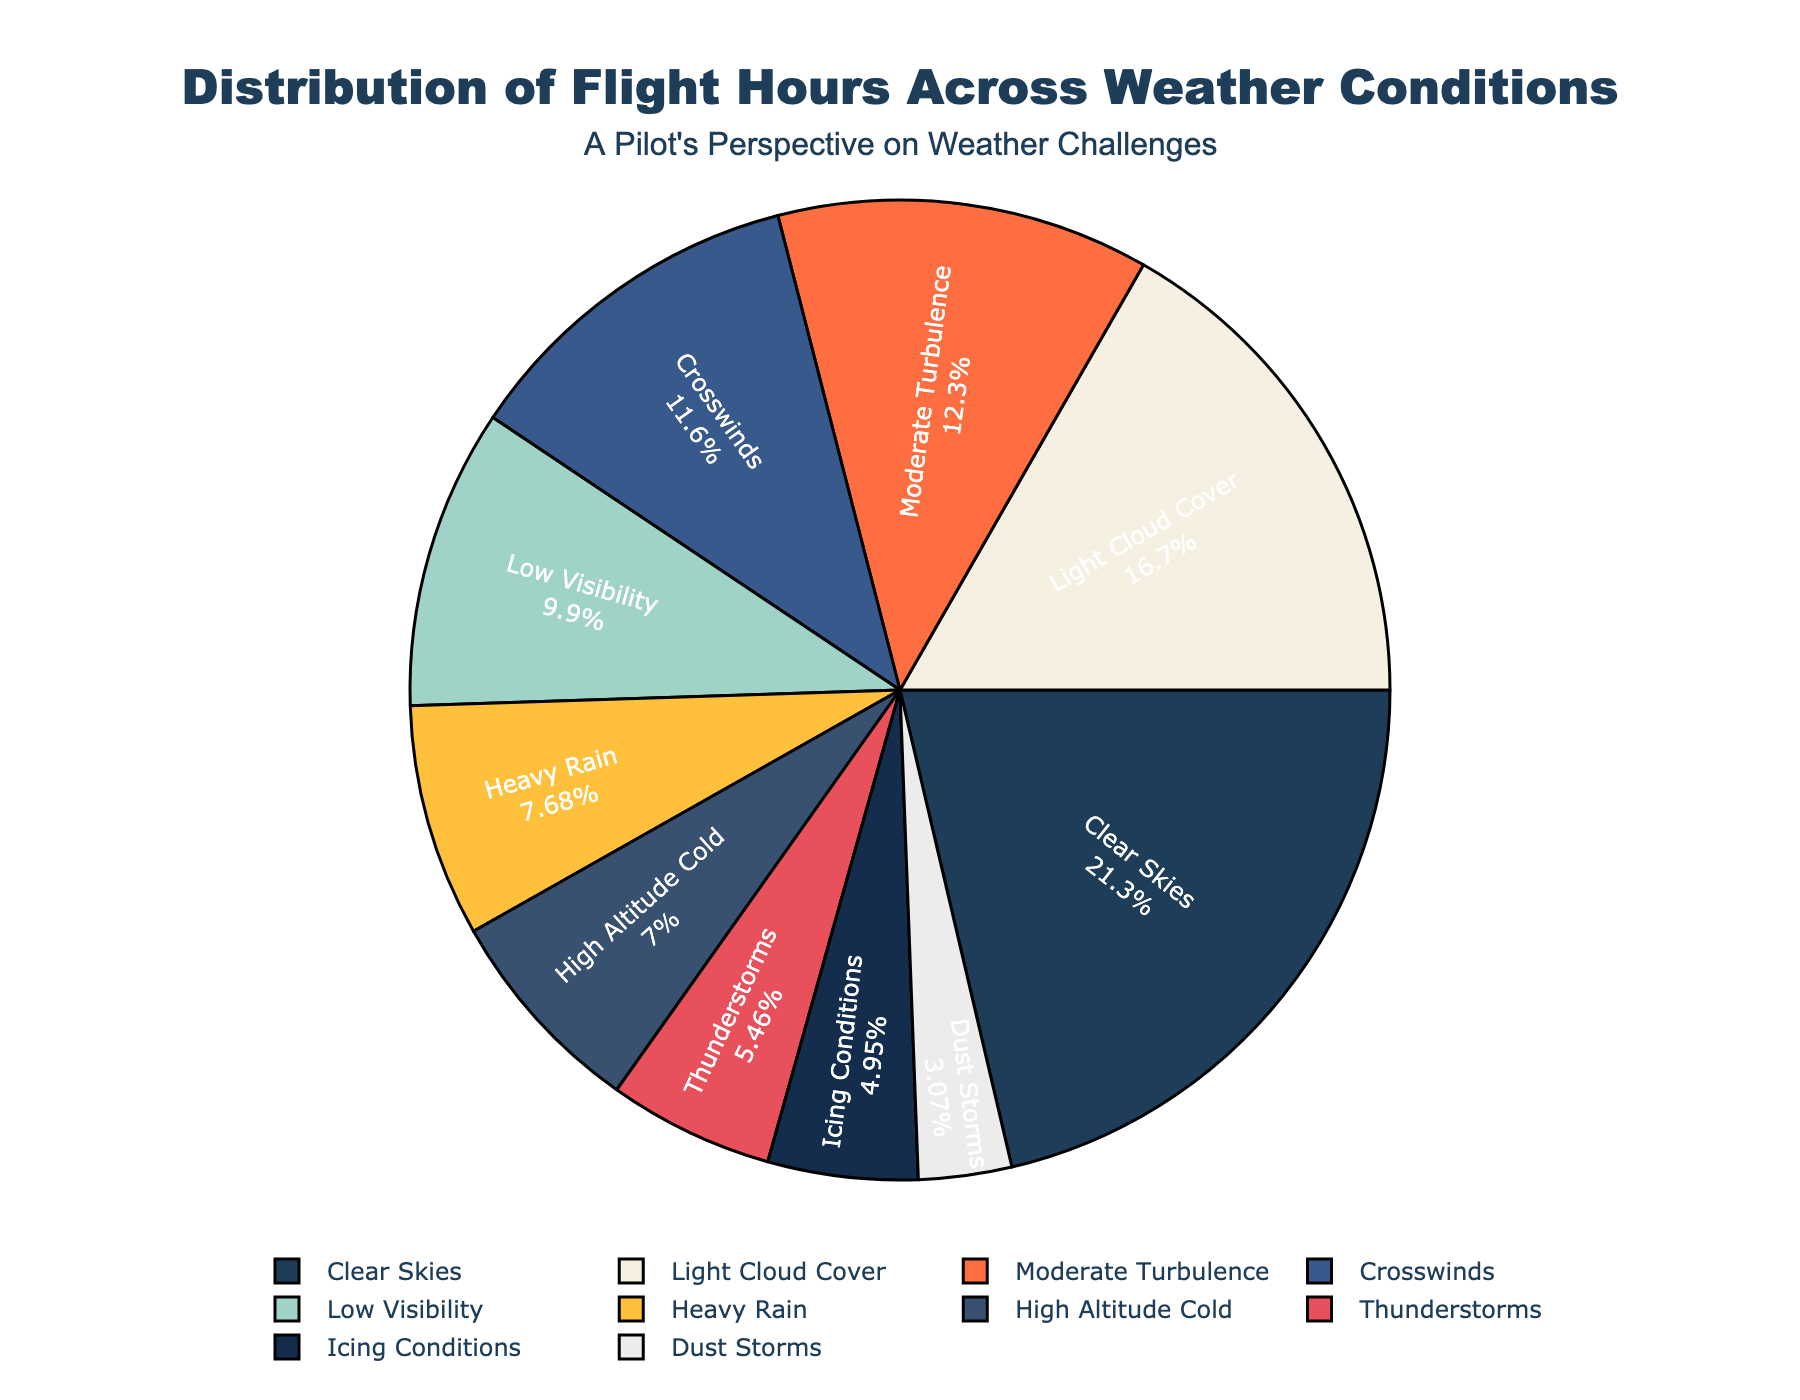Which weather condition has the most flight hours? Looking at the pie chart, the largest segment is labeled with "Clear Skies" which corresponds to the highest percentage. Therefore, Clear Skies has the most flight hours.
Answer: Clear Skies How many more flight hours are there in clear skies compared to crosswinds? Clear Skies has 1250 flight hours and Crosswinds has 680. Subtracting the smaller from the larger number, we get 1250 - 680 = 570.
Answer: 570 What is the combined percentage of flight hours in Heavy Rain and Thunderstorms? We identify the segments labeled Heavy Rain and Thunderstorms. Adding their percentages together, assuming Heavy Rain is ~10% (450/5860) and Thunderstorms is ~5.5% (320/5860), we get approximately 15.5%.
Answer: ~15.5% Which weather conditions have fewer flight hours than Low Visibility? Low Visibility has 580 flight hours. The conditions with fewer flight hours are Moderate Turbulence (720), Heavy Rain (450), Thunderstorms (320), Icing Conditions (290), High Altitude Cold (410), and Dust Storms (180).
Answer: Moderate Turbulence, Heavy Rain, Thunderstorms, Icing Conditions, High Altitude Cold, Dust Storms Do Icing Conditions or Dust Storms have a smaller share of flight hours in the distribution? Identify the segments for Icing Conditions and Dust Storms. Dust Storms' segment is visibly smaller than Icing Conditions’.
Answer: Dust Storms What is the average flight hour count for all weather conditions? Sum all flight hours: 1250+980+720+450+680+320+580+290+410+180 = 5860. Divide by the number of conditions (10), 5860/10 = 586.
Answer: 586 Which three weather conditions have the highest flight hours? The three largest segments are Clear Skies (1250 hours), Light Cloud Cover (980 hours), and Moderate Turbulence (720 hours).
Answer: Clear Skies, Light Cloud Cover, Moderate Turbulence Is the proportion of flight hours in thunderstorms less than in high-altitude cold conditions? Thunderstorms have 320 flight hours and High Altitude Cold has 410. Convert to percentages: (320/5860) is ~5.5% and (410/5860) is ~7%. Therefore, Thunderstorms has a smaller proportion.
Answer: Yes What is the total percentage of flight hours for Icing Conditions and Light Cloud Cover combined? Compute the individual percentages: Icing Conditions (290) ~5% and Light Cloud Cover (980) ~16.7%. Summing these gives 5% + 16.7% = 21.7%.
Answer: ~21.7% 